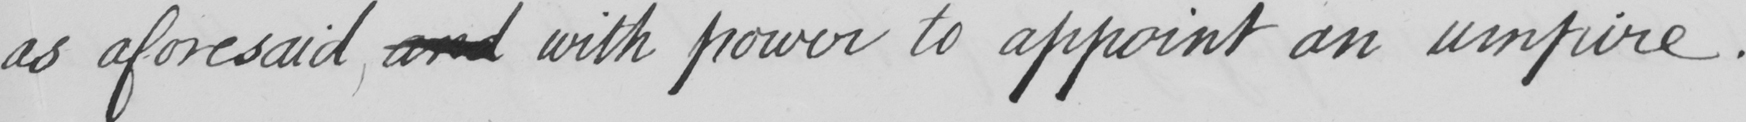What is written in this line of handwriting? as aforesaid and with power to appoint an umpire . 